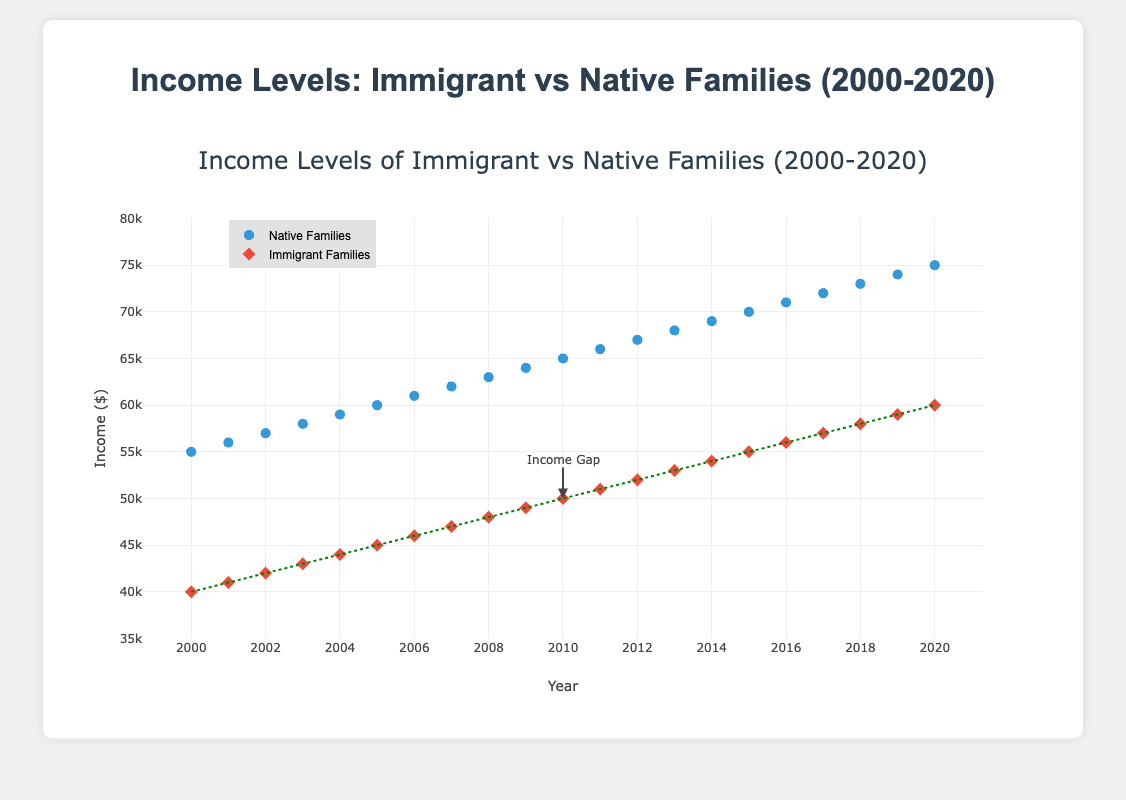What is the title of the figure? The title of the figure is displayed at the top and reads "Income Levels of Immigrant vs Native Families (2000-2020)".
Answer: Income Levels of Immigrant vs Native Families (2000-2020) Which group uses diamond markers in the plot? By observing the different marker shapes, the group using diamond markers is the Immigrant Families.
Answer: Immigrant Families What is the income level of native families in 2010? Locate the data point for native families on the y-axis corresponding to 2010 on the x-axis. The income level is marked at $65,000.
Answer: $65,000 Over the period from 2000 to 2020, did the income gap between immigrant and native families increase, decrease, or remain constant? Examine the green dashed line representing the income gap between immigrant and native families. Initially, the gap appears wider but narrows slightly over time, suggesting a decrease.
Answer: Decrease Compare the income levels of immigrant and native families in 2015. Which group had a higher income and by how much? Find the 2015 markers and compare their y-values. Native families had $70,000, and immigrant families had $55,000. The difference is $70,000 - $55,000 = $15,000.
Answer: Native families by $15,000 In which year were the incomes of immigrant families first recorded at over $50,000? Observe the y-values for immigrant families and identify the first year beyond $50,000. This happens in 2012 where the income is $52,000.
Answer: 2012 How many years show data points for both native and immigrant families? Count the markers from 2000 to 2020 for both native and immigrant families. Each year within this range contains data points for both groups.
Answer: 21 years What is the overall income trend for native families from 2000 to 2020? Observe the scatter plot for native families' data points and note their movement from 2000 to 2020. The trend shows a consistent increase.
Answer: Increasing To which data point does the annotation "Income Gap" point? The annotation "Income Gap" points to the year 2010 with an immigrant families' data point at $50,000.
Answer: 2010, $50,000 In 2006, how much more did native families earn compared to immigrant families? For the year 2006, find native families earning $61,000 and immigrant families earning $46,000. The difference is $61,000 - $46,000 = $15,000.
Answer: $15,000 